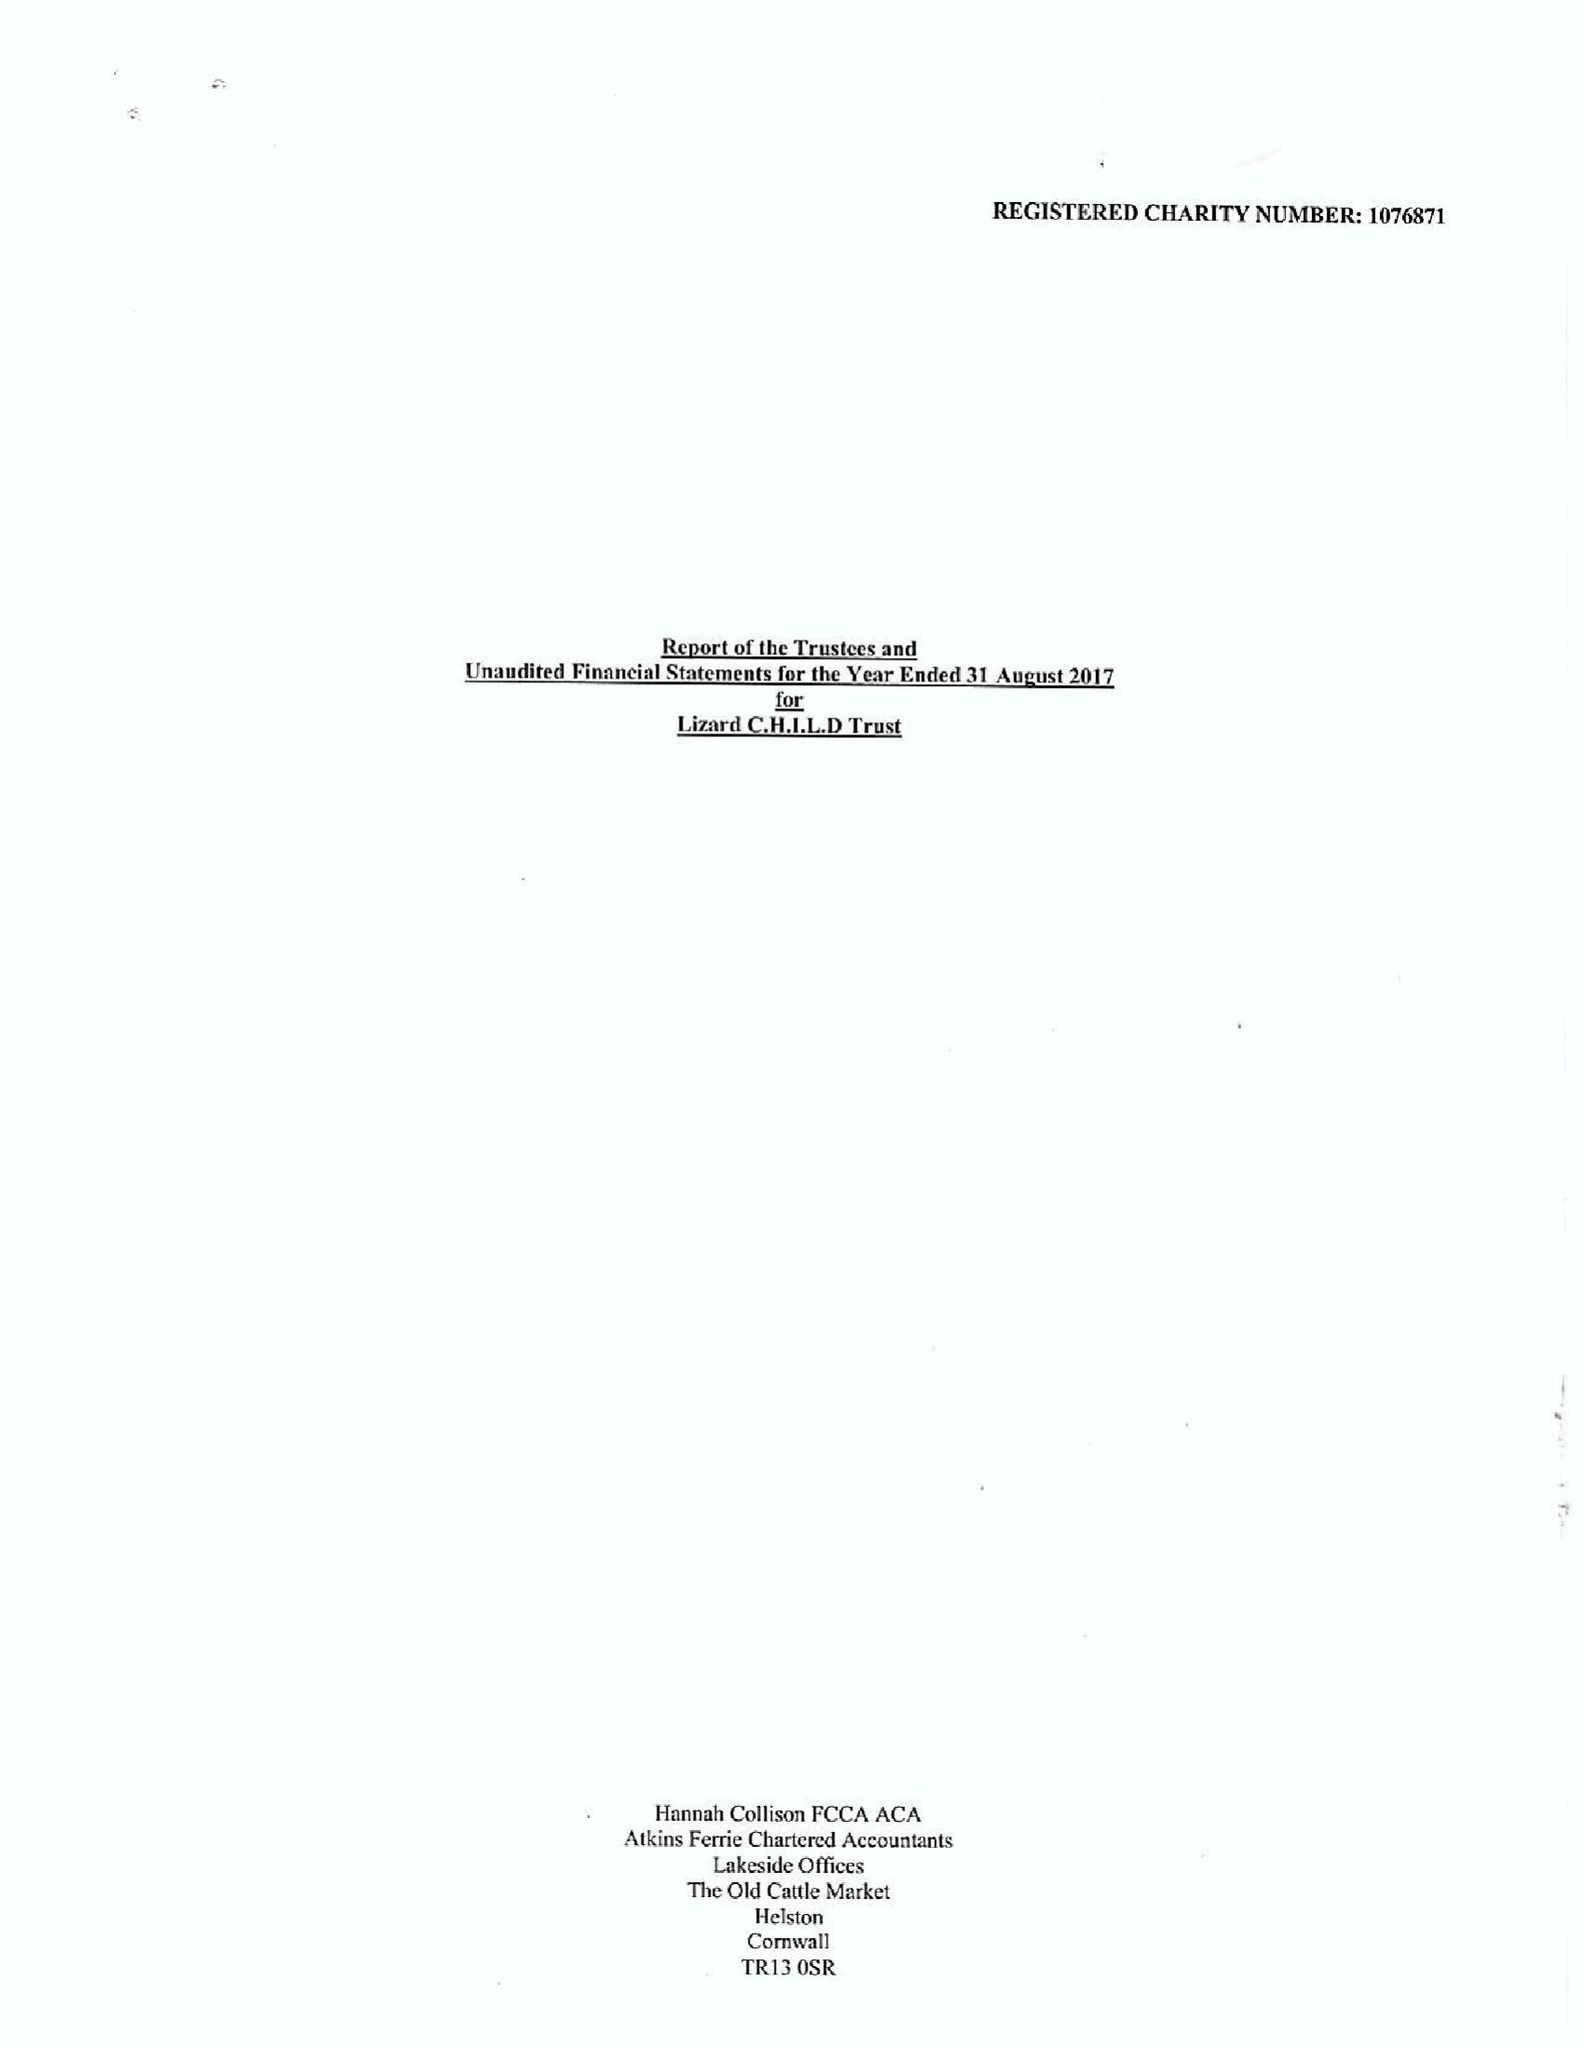What is the value for the charity_name?
Answer the question using a single word or phrase. Lizard Child Trust 